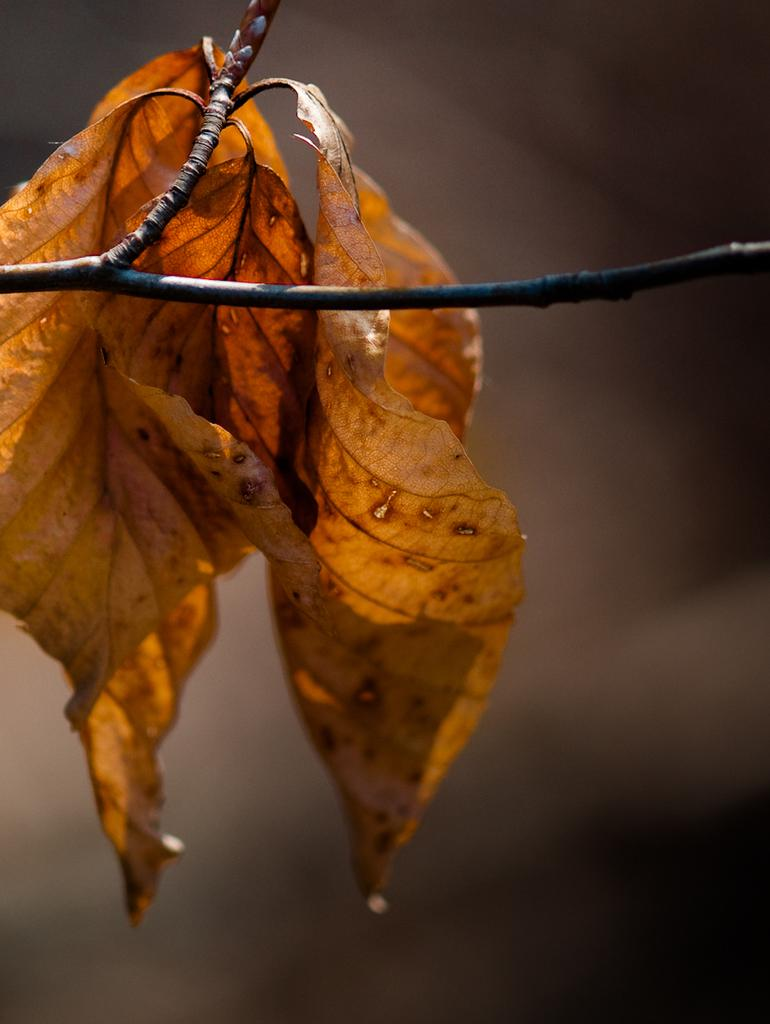How many leaves are visible on the tree branch in the foreground of the image? There are four leaves on a tree branch in the foreground of the image. What can be observed about the background of the image? The background of the image is blurred. What type of news can be heard coming from the radio in the image? There is no radio present in the image, so it's not possible to determine what, if any, news might be heard. 